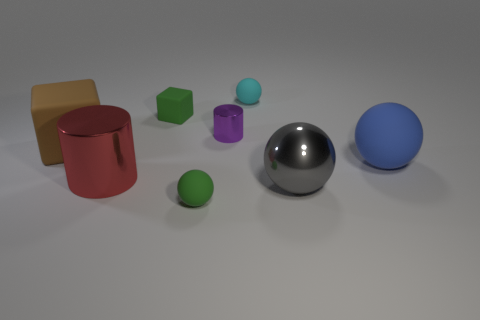Subtract all blue balls. How many balls are left? 3 Subtract 2 spheres. How many spheres are left? 2 Subtract all matte balls. How many balls are left? 1 Subtract all yellow spheres. Subtract all gray cylinders. How many spheres are left? 4 Add 1 big cyan cylinders. How many objects exist? 9 Subtract all cubes. How many objects are left? 6 Add 5 blue objects. How many blue objects exist? 6 Subtract 1 green spheres. How many objects are left? 7 Subtract all brown cubes. Subtract all big blue objects. How many objects are left? 6 Add 1 small green matte blocks. How many small green matte blocks are left? 2 